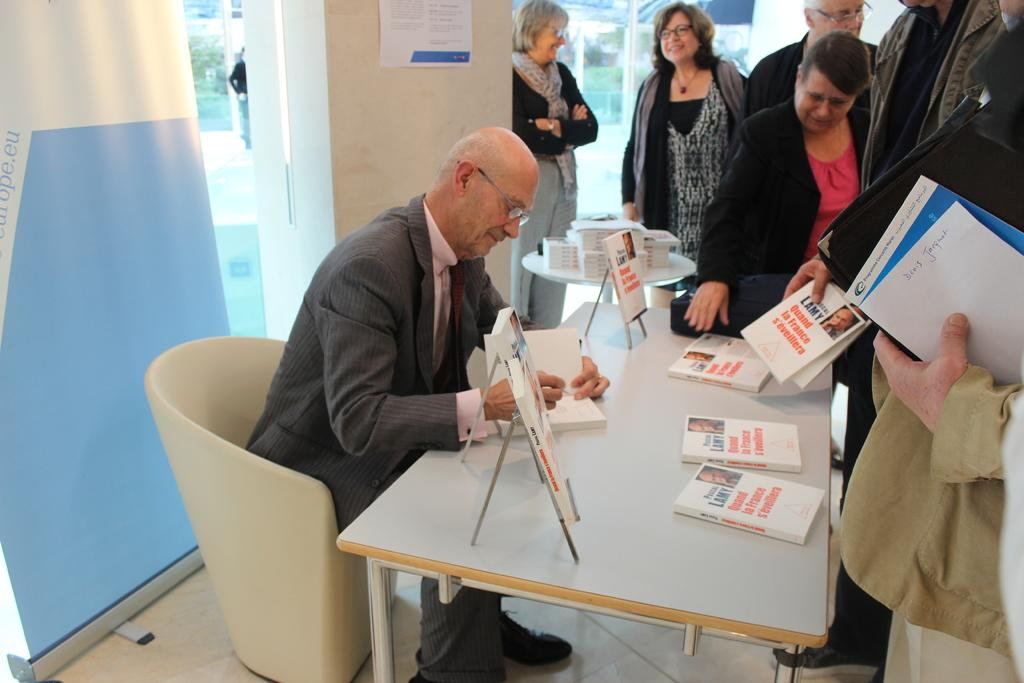What is the man in the image doing? The man is sitting on a sofa in the image. Where is the sofa located in relation to the table? The sofa is near a table in the image. What items can be seen on the table? Books are kept on the table in the image. What is the position of the people in the image? There are people standing near the table in the image. What additional element is present in the image? There is a poster in the image. What type of news can be seen on the elbow of the man in the image? There is no news or any reference to news in the image; the man's elbow is not mentioned in the provided facts. 